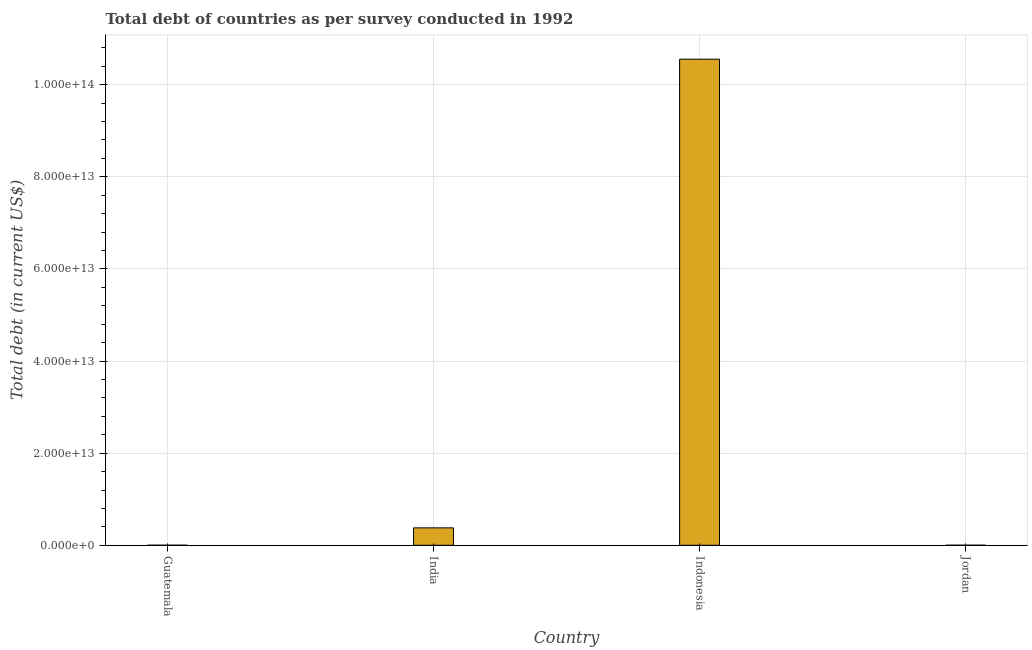What is the title of the graph?
Provide a succinct answer. Total debt of countries as per survey conducted in 1992. What is the label or title of the Y-axis?
Keep it short and to the point. Total debt (in current US$). What is the total debt in India?
Your answer should be very brief. 3.78e+12. Across all countries, what is the maximum total debt?
Provide a short and direct response. 1.06e+14. Across all countries, what is the minimum total debt?
Your answer should be compact. 5.51e+09. In which country was the total debt maximum?
Your answer should be very brief. Indonesia. In which country was the total debt minimum?
Keep it short and to the point. Jordan. What is the sum of the total debt?
Your answer should be compact. 1.09e+14. What is the difference between the total debt in Indonesia and Jordan?
Provide a short and direct response. 1.06e+14. What is the average total debt per country?
Provide a short and direct response. 2.73e+13. What is the median total debt?
Offer a very short reply. 1.90e+12. In how many countries, is the total debt greater than 8000000000000 US$?
Provide a succinct answer. 1. What is the ratio of the total debt in India to that in Jordan?
Your answer should be compact. 686.39. What is the difference between the highest and the second highest total debt?
Offer a very short reply. 1.02e+14. Is the sum of the total debt in Guatemala and India greater than the maximum total debt across all countries?
Make the answer very short. No. What is the difference between the highest and the lowest total debt?
Ensure brevity in your answer.  1.06e+14. In how many countries, is the total debt greater than the average total debt taken over all countries?
Make the answer very short. 1. What is the difference between two consecutive major ticks on the Y-axis?
Provide a succinct answer. 2.00e+13. What is the Total debt (in current US$) of Guatemala?
Keep it short and to the point. 8.55e+09. What is the Total debt (in current US$) of India?
Your answer should be compact. 3.78e+12. What is the Total debt (in current US$) in Indonesia?
Your answer should be very brief. 1.06e+14. What is the Total debt (in current US$) of Jordan?
Provide a short and direct response. 5.51e+09. What is the difference between the Total debt (in current US$) in Guatemala and India?
Your answer should be compact. -3.77e+12. What is the difference between the Total debt (in current US$) in Guatemala and Indonesia?
Offer a terse response. -1.06e+14. What is the difference between the Total debt (in current US$) in Guatemala and Jordan?
Offer a terse response. 3.04e+09. What is the difference between the Total debt (in current US$) in India and Indonesia?
Give a very brief answer. -1.02e+14. What is the difference between the Total debt (in current US$) in India and Jordan?
Provide a succinct answer. 3.78e+12. What is the difference between the Total debt (in current US$) in Indonesia and Jordan?
Offer a very short reply. 1.06e+14. What is the ratio of the Total debt (in current US$) in Guatemala to that in India?
Your response must be concise. 0. What is the ratio of the Total debt (in current US$) in Guatemala to that in Indonesia?
Your answer should be compact. 0. What is the ratio of the Total debt (in current US$) in Guatemala to that in Jordan?
Offer a terse response. 1.55. What is the ratio of the Total debt (in current US$) in India to that in Indonesia?
Your answer should be compact. 0.04. What is the ratio of the Total debt (in current US$) in India to that in Jordan?
Make the answer very short. 686.39. What is the ratio of the Total debt (in current US$) in Indonesia to that in Jordan?
Your response must be concise. 1.92e+04. 